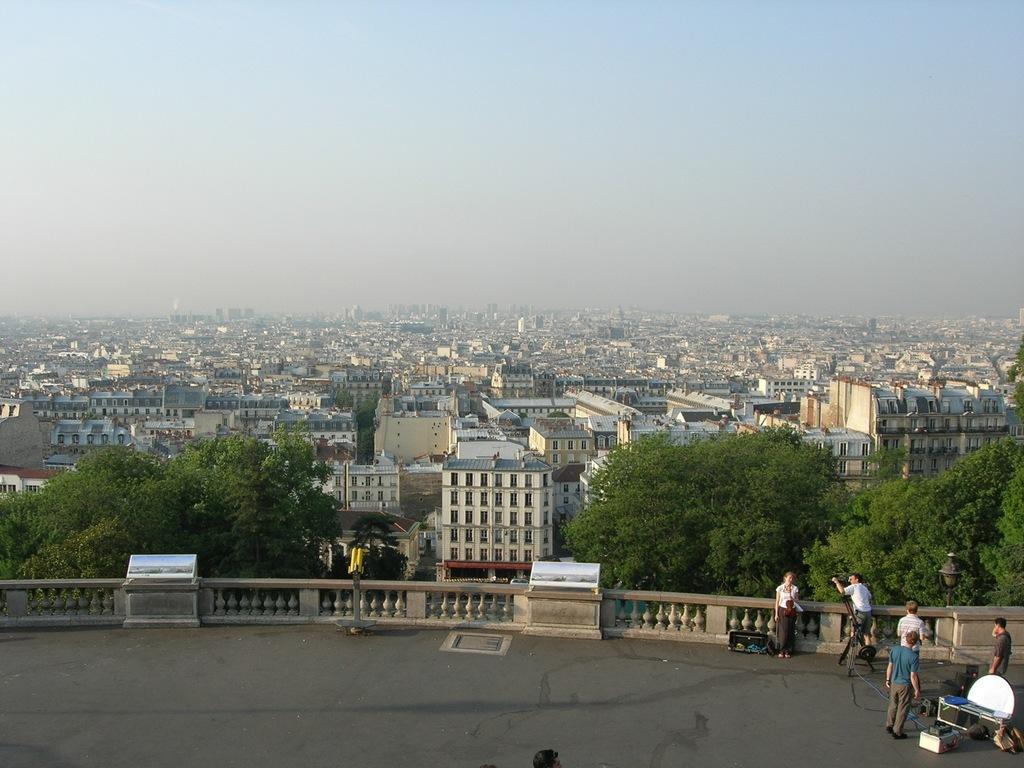What is located in the center of the image? There is a fence in the center of the image. What are the people near the fence doing? The people standing near the fence are holding objects. What can be seen in the background of the image? There is a sky, buildings, and trees visible in the background of the image. What type of hat is the structure made of in the image? There is no structure or hat present in the image; it features a fence and people holding objects. 